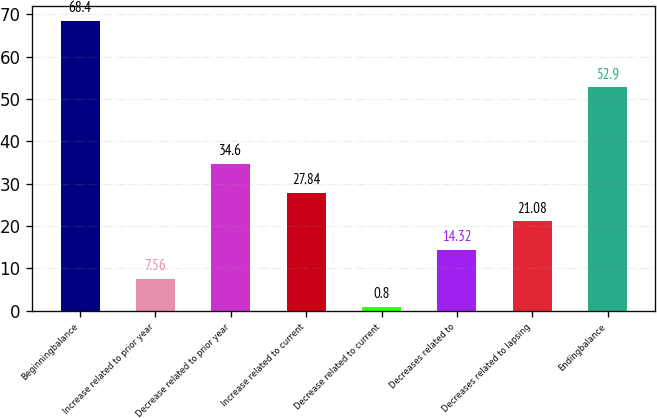Convert chart to OTSL. <chart><loc_0><loc_0><loc_500><loc_500><bar_chart><fcel>Beginningbalance<fcel>Increase related to prior year<fcel>Decrease related to prior year<fcel>Increase related to current<fcel>Decrease related to current<fcel>Decreases related to<fcel>Decreases related to lapsing<fcel>Endingbalance<nl><fcel>68.4<fcel>7.56<fcel>34.6<fcel>27.84<fcel>0.8<fcel>14.32<fcel>21.08<fcel>52.9<nl></chart> 